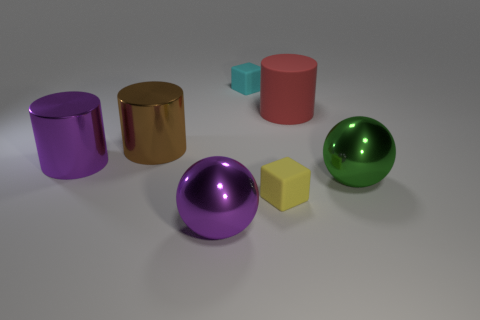How many objects are in the image, and can you describe their colors and shapes? There are six objects in the image: a purple cylinder, a gold cylinder, a red cylinder, a pink cube, a yellow cube, and a green sphere.  Which object appears closest to the front? The green sphere appears closest to the front of the image.  Are there any reflective objects in the scene? Yes, the purple and gold cylinders, as well as the green sphere, appear to have reflective surfaces. 